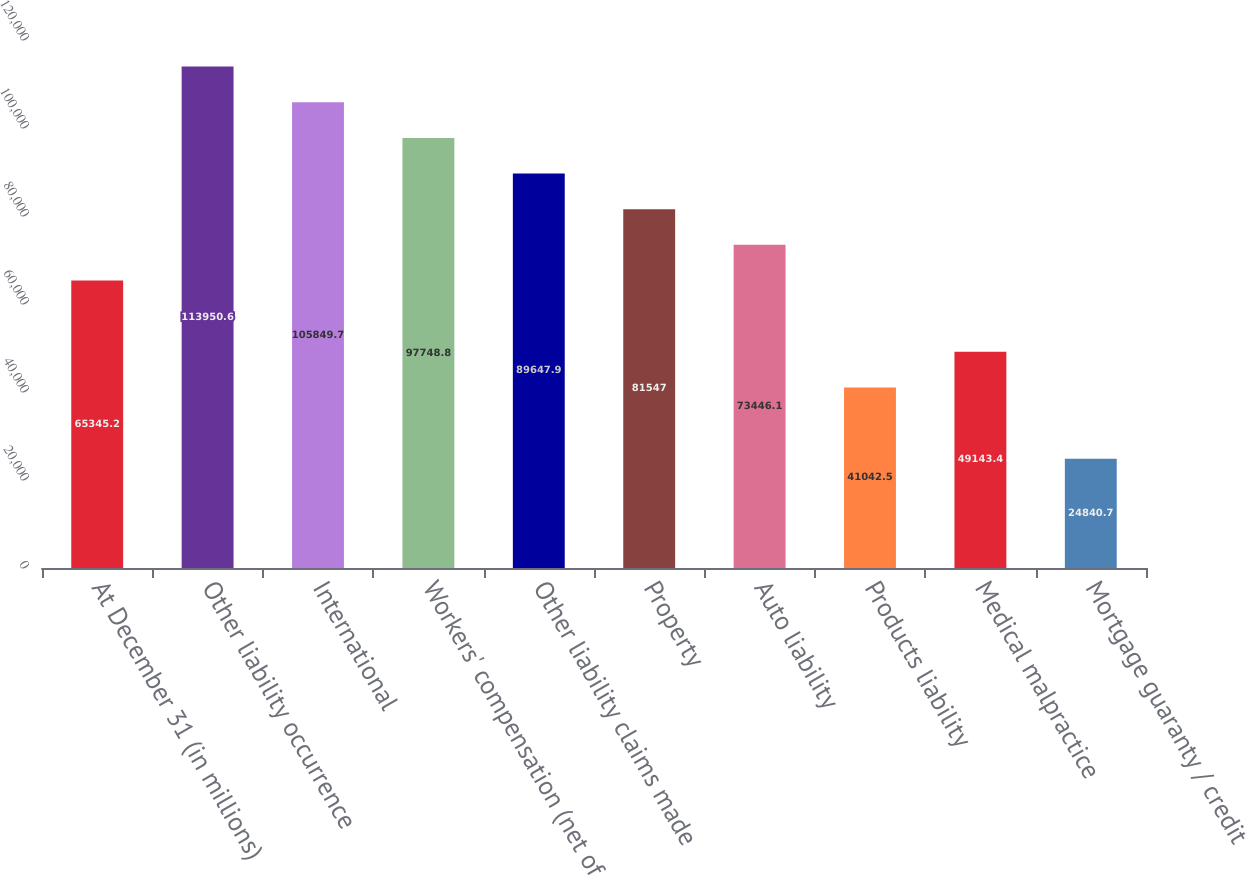<chart> <loc_0><loc_0><loc_500><loc_500><bar_chart><fcel>At December 31 (in millions)<fcel>Other liability occurrence<fcel>International<fcel>Workers' compensation (net of<fcel>Other liability claims made<fcel>Property<fcel>Auto liability<fcel>Products liability<fcel>Medical malpractice<fcel>Mortgage guaranty / credit<nl><fcel>65345.2<fcel>113951<fcel>105850<fcel>97748.8<fcel>89647.9<fcel>81547<fcel>73446.1<fcel>41042.5<fcel>49143.4<fcel>24840.7<nl></chart> 